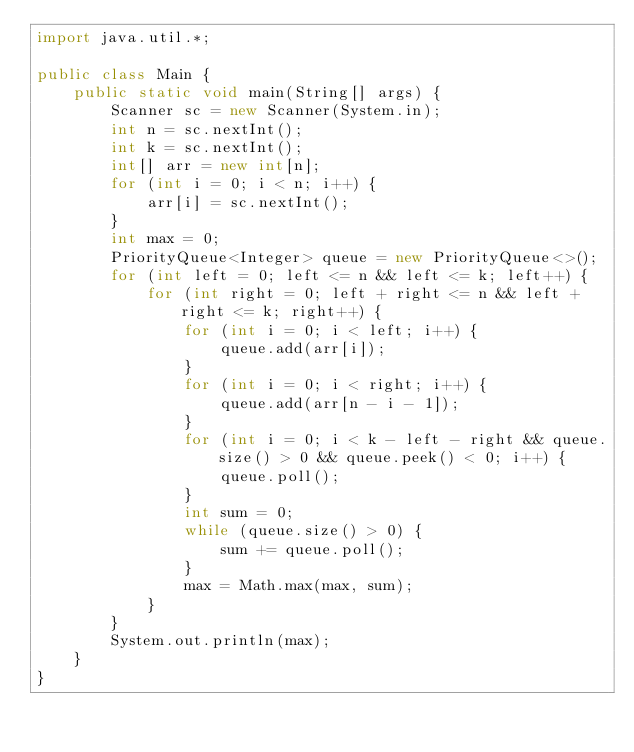Convert code to text. <code><loc_0><loc_0><loc_500><loc_500><_Java_>import java.util.*;

public class Main {
    public static void main(String[] args) {
        Scanner sc = new Scanner(System.in);
        int n = sc.nextInt();
        int k = sc.nextInt();
        int[] arr = new int[n];
        for (int i = 0; i < n; i++) {
            arr[i] = sc.nextInt();
        }
        int max = 0;
        PriorityQueue<Integer> queue = new PriorityQueue<>();
        for (int left = 0; left <= n && left <= k; left++) {
            for (int right = 0; left + right <= n && left + right <= k; right++) {
                for (int i = 0; i < left; i++) {
                    queue.add(arr[i]);
                }
                for (int i = 0; i < right; i++) {
                    queue.add(arr[n - i - 1]);
                }
                for (int i = 0; i < k - left - right && queue.size() > 0 && queue.peek() < 0; i++) {
                    queue.poll();
                }
                int sum = 0;
                while (queue.size() > 0) {
                    sum += queue.poll();
                }
                max = Math.max(max, sum);
            }
        }
        System.out.println(max);
    }
}</code> 